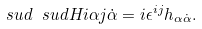Convert formula to latex. <formula><loc_0><loc_0><loc_500><loc_500>\ s u d { \ s u d H i \alpha } j { \dot { \alpha } } = i \epsilon ^ { i j } h _ { \alpha \dot { \alpha } } .</formula> 